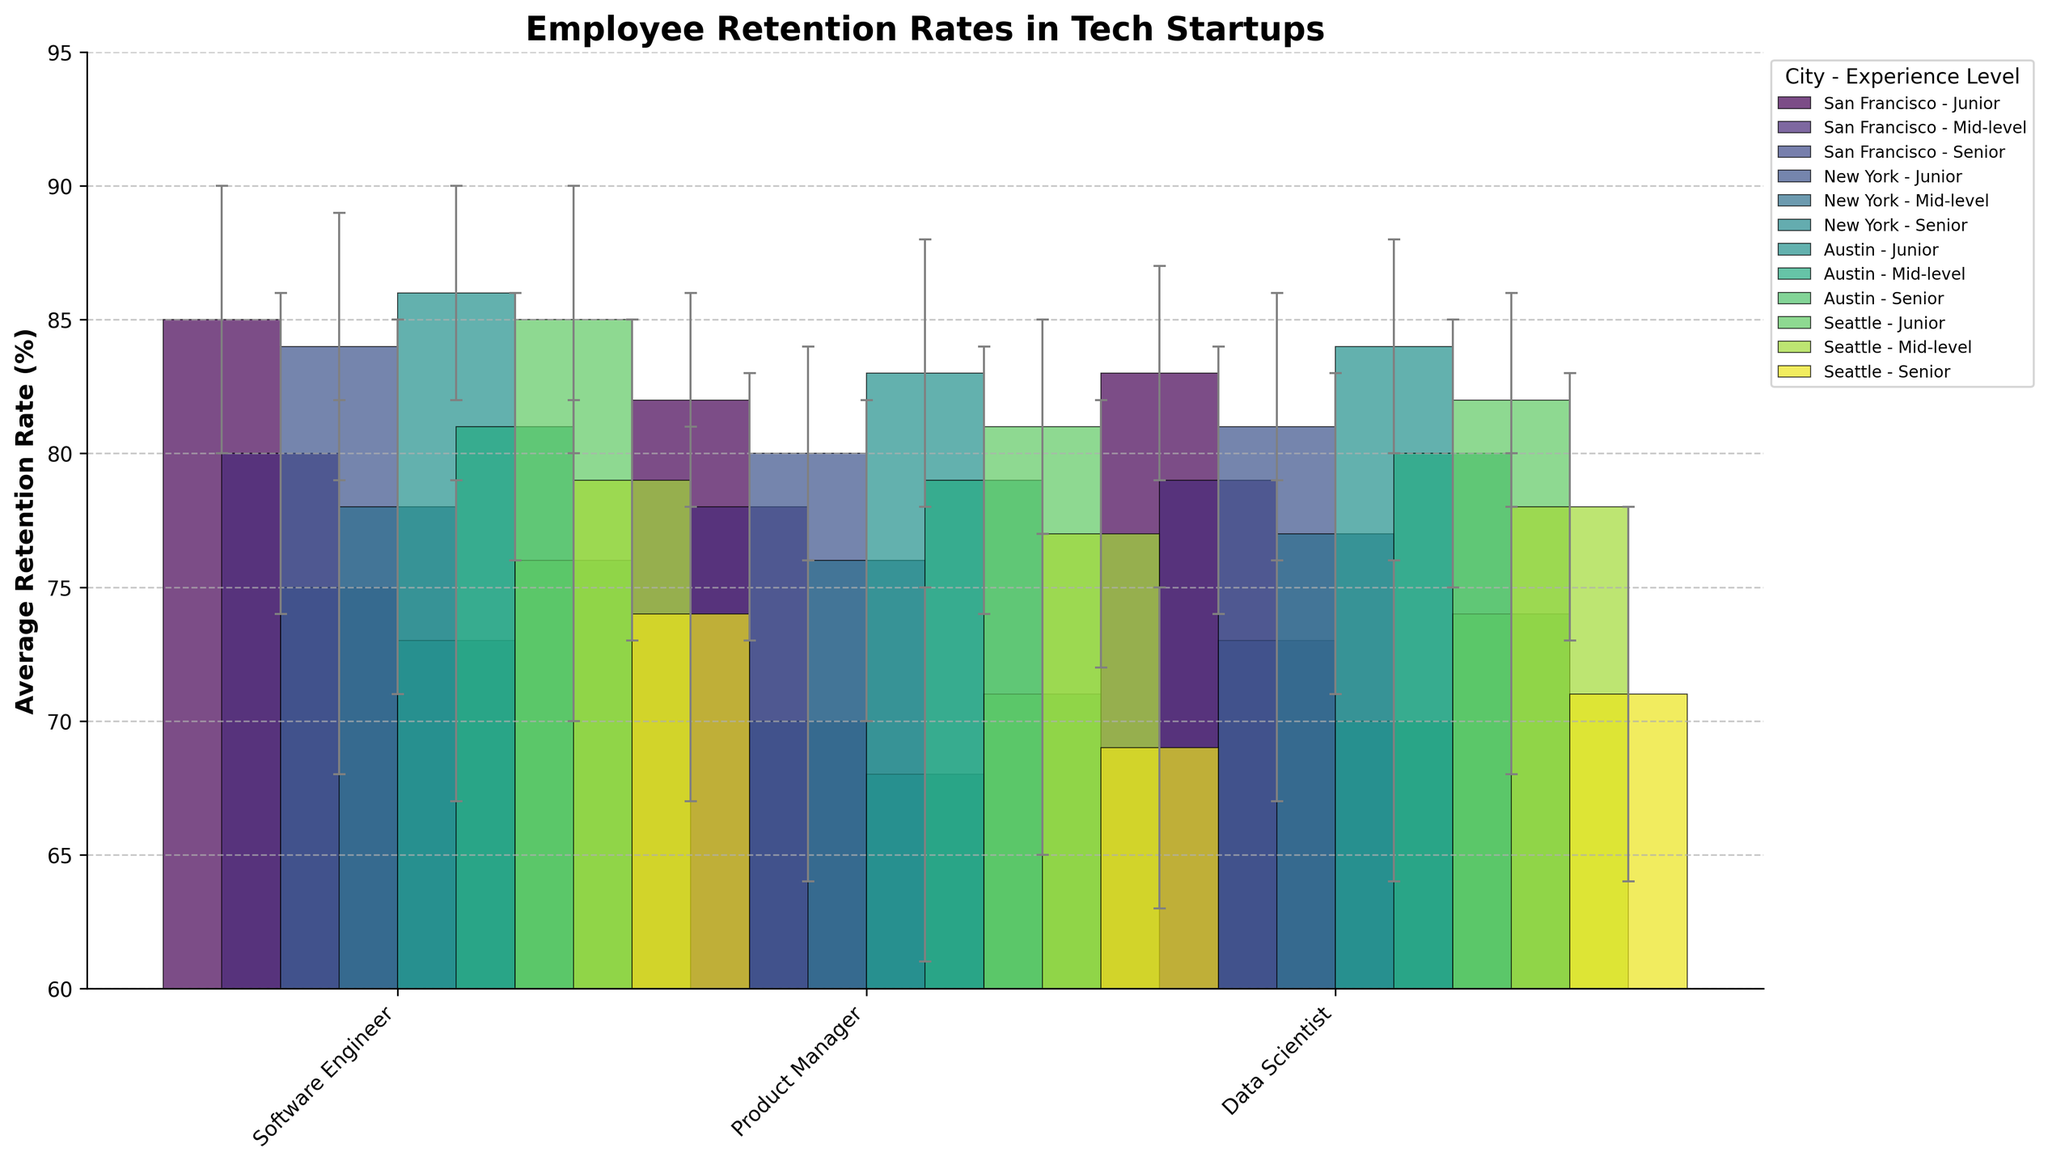What is the title of the chart? The title of the chart is usually located at the top of the figure and provides a summary of what the chart is about.
Answer: Employee Retention Rates in Tech Startups What is the average retention rate for junior software engineers in Austin? The bar representing junior software engineers in Austin needs to be identified, and then you can read the value from the bar or the label.
Answer: 86% Which city has the highest average retention rate for mid-level data scientists? Locate the bars representing mid-level data scientists for each city and compare their heights to determine which is the highest.
Answer: Austin What is the difference in retention rate between mid-level and senior product managers in Seattle? Find the bar heights for mid-level and senior product managers in Seattle and subtract the senior rate from the mid-level rate.
Answer: 8% Are junior roles more likely to have higher retention rates than senior roles across all cities? Compare the heights of the bars labeled as junior with those labeled as senior for each role and city to see if juniors consistently have higher bars.
Answer: Yes What is the range of retention rates for software engineers across all experience levels in New York? Identify the highest and lowest bars for software engineers in New York and find the difference between these values.
Answer: 11% (84% - 73%) How does the retention rate for senior data scientists in San Francisco compare to those in Seattle? Compare the heights of the bars representing senior data scientists in San Francisco and Seattle to see which is taller or if they are the same.
Answer: San Francisco is higher What role has the most consistent retention rate across all cities based on standard deviations? Observe the error bars for each role across cities and identify the role with the smallest range in error bar lengths.
Answer: Junior Product Manager Which category has the largest error bar, indicating the highest variability in retention rates? Look for the longest error bars in the chart and note the associated category (city, role, and experience level).
Answer: Senior Software Engineer in San Francisco Between which cities is the retention rate for mid-level product managers most different? Compare the heights of the bars for mid-level product managers across cities to find the largest difference.
Answer: San Francisco and Seattle 